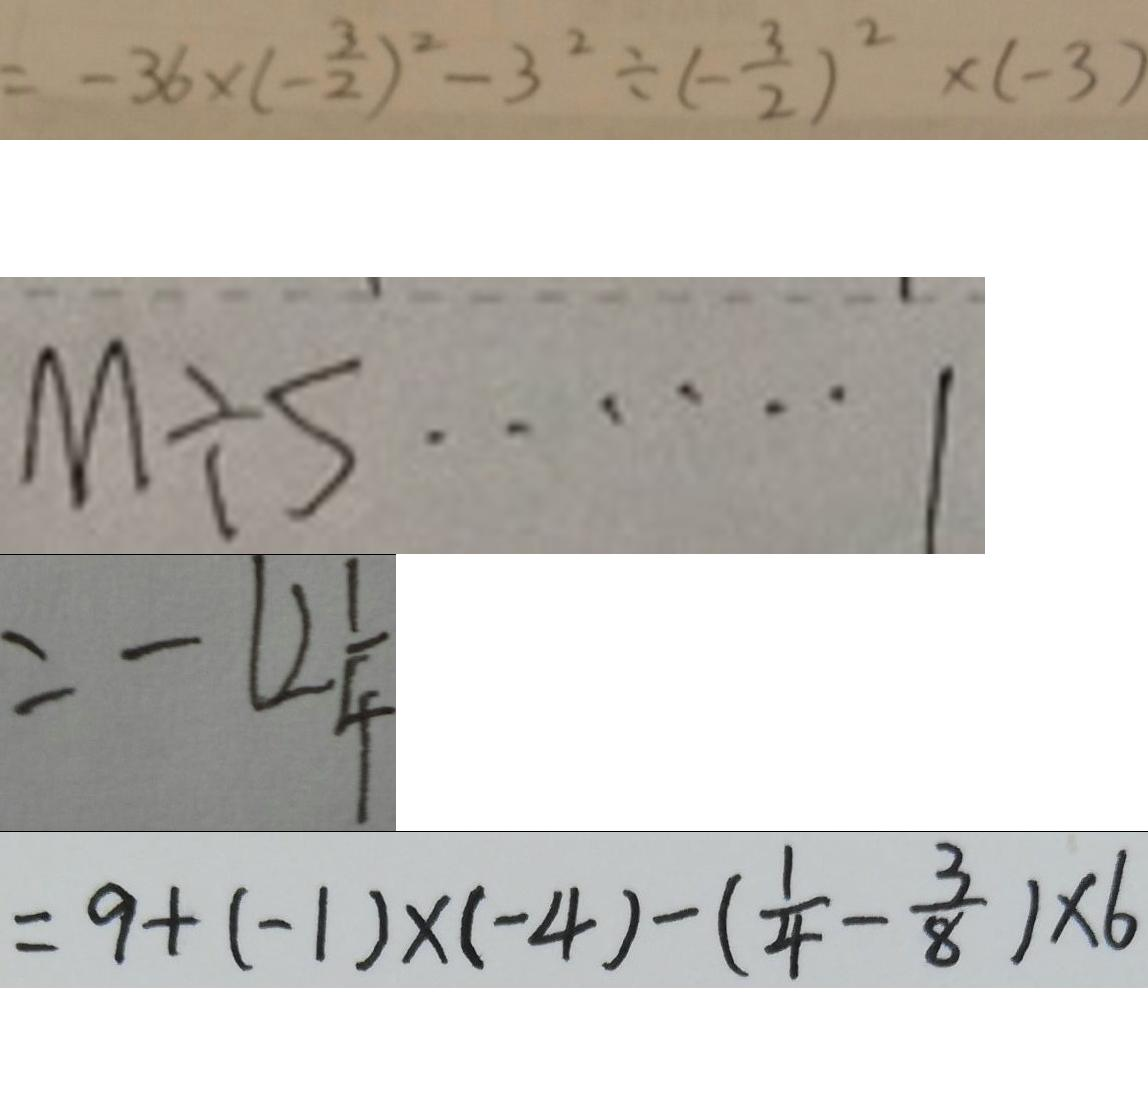Convert formula to latex. <formula><loc_0><loc_0><loc_500><loc_500>= - 3 6 \times ( - \frac { 3 } { 2 } ) ^ { 2 } - 3 ^ { 2 } \div ( - \frac { 3 } { 2 } ) ^ { 2 } \times ( - 3 ) 
 M \div 5 \cdots 1 
 = - 1 2 \frac { 1 } { 4 } 
 = 9 + ( - 1 ) \times ( - 4 ) - ( \frac { 1 } { 4 } - \frac { 3 } { 8 } ) \times 6</formula> 